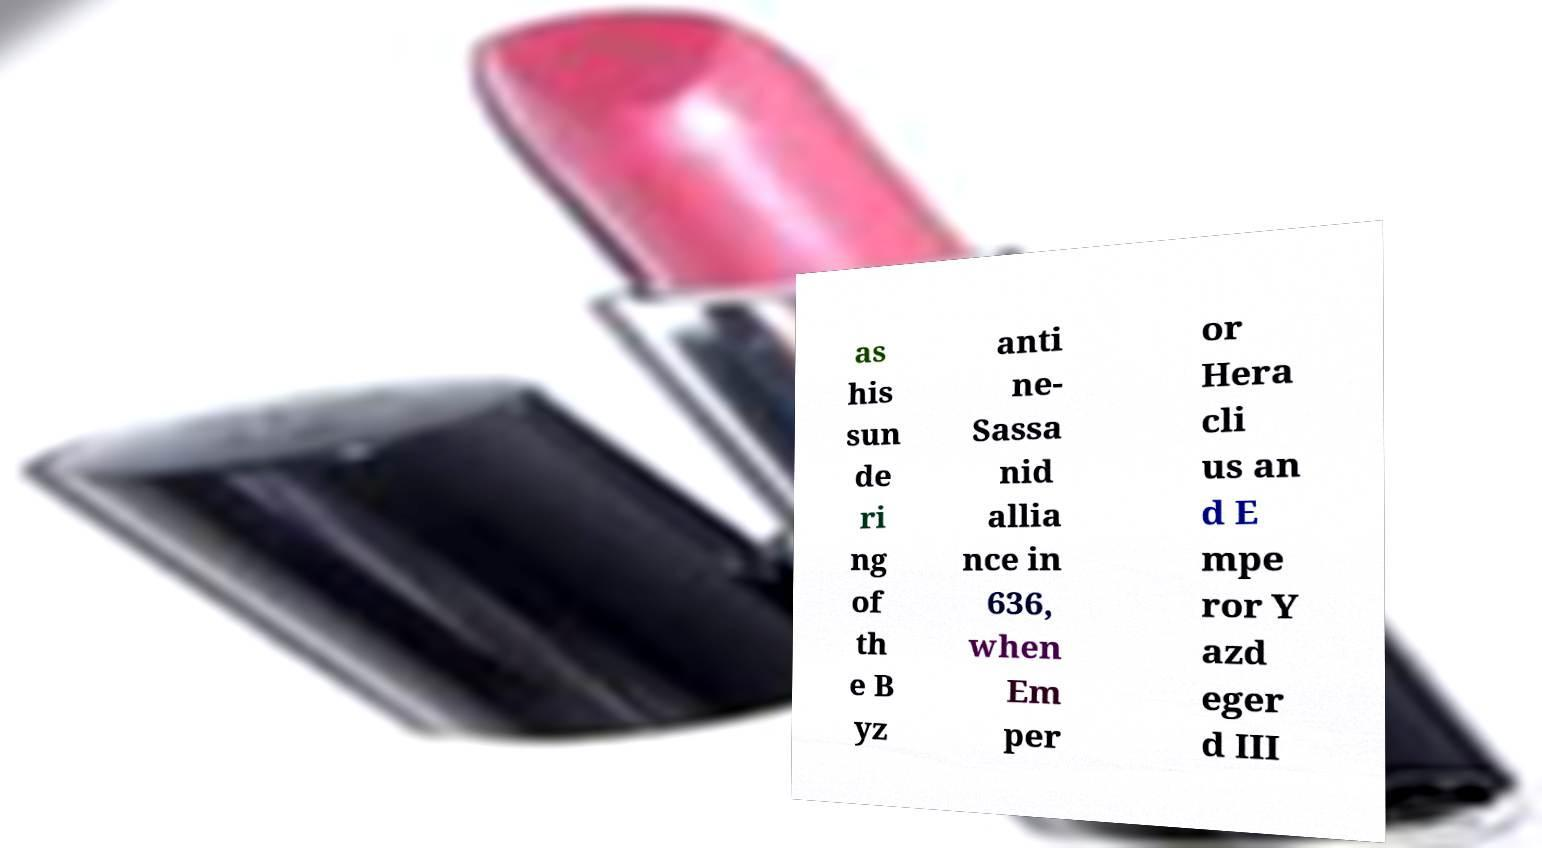Can you accurately transcribe the text from the provided image for me? as his sun de ri ng of th e B yz anti ne- Sassa nid allia nce in 636, when Em per or Hera cli us an d E mpe ror Y azd eger d III 